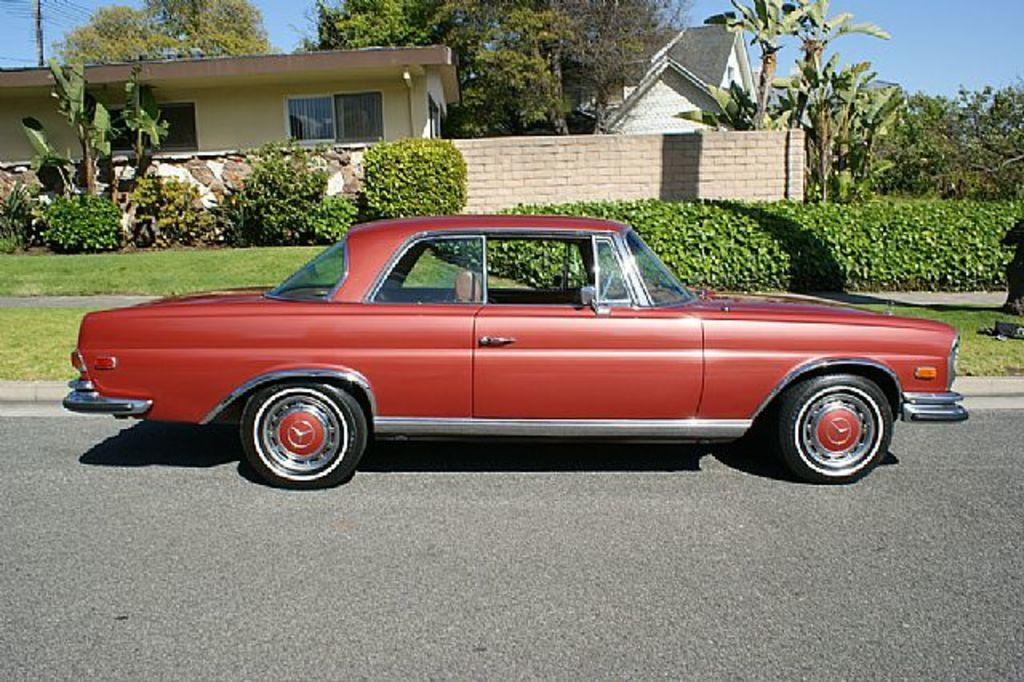What is on the road in the image? There is a vehicle on the road in the image. What can be seen on the ground in the image? The ground is visible with grass in the image. What type of vegetation is present in the image? There are trees and plants in the image. What type of structures can be seen in the image? There are houses with windows in the image. What is visible in the sky in the image? The sky is visible in the image. Can you see the father walking up the hill in the image? There is no father or hill present in the image. Is there any dust visible in the image? There is no dust visible in the image. 